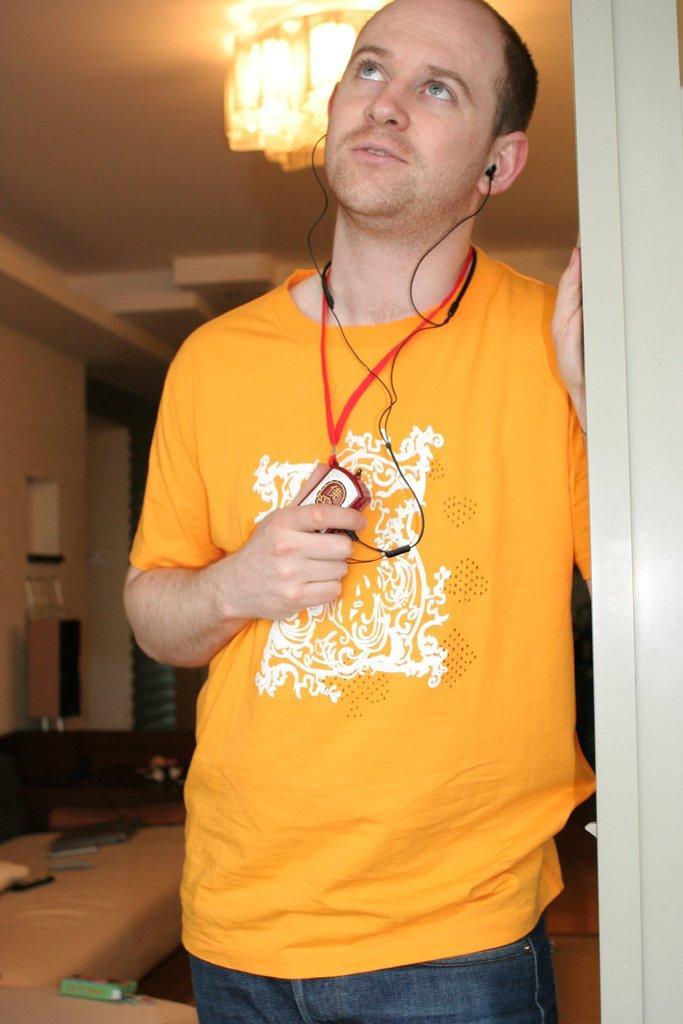How would you summarize this image in a sentence or two? In this picture we can see a man standing and holding a device with this hand, earphone, sofa, speaker and some objects and in the background we can see the wall. 